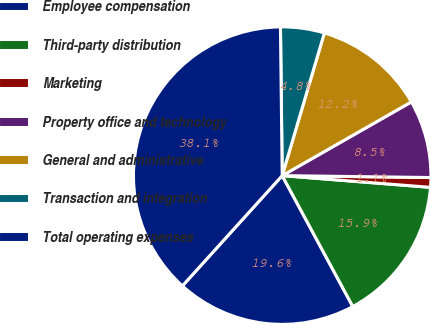Convert chart. <chart><loc_0><loc_0><loc_500><loc_500><pie_chart><fcel>Employee compensation<fcel>Third-party distribution<fcel>Marketing<fcel>Property office and technology<fcel>General and administrative<fcel>Transaction and integration<fcel>Total operating expenses<nl><fcel>19.58%<fcel>15.87%<fcel>1.05%<fcel>8.46%<fcel>12.17%<fcel>4.76%<fcel>38.1%<nl></chart> 